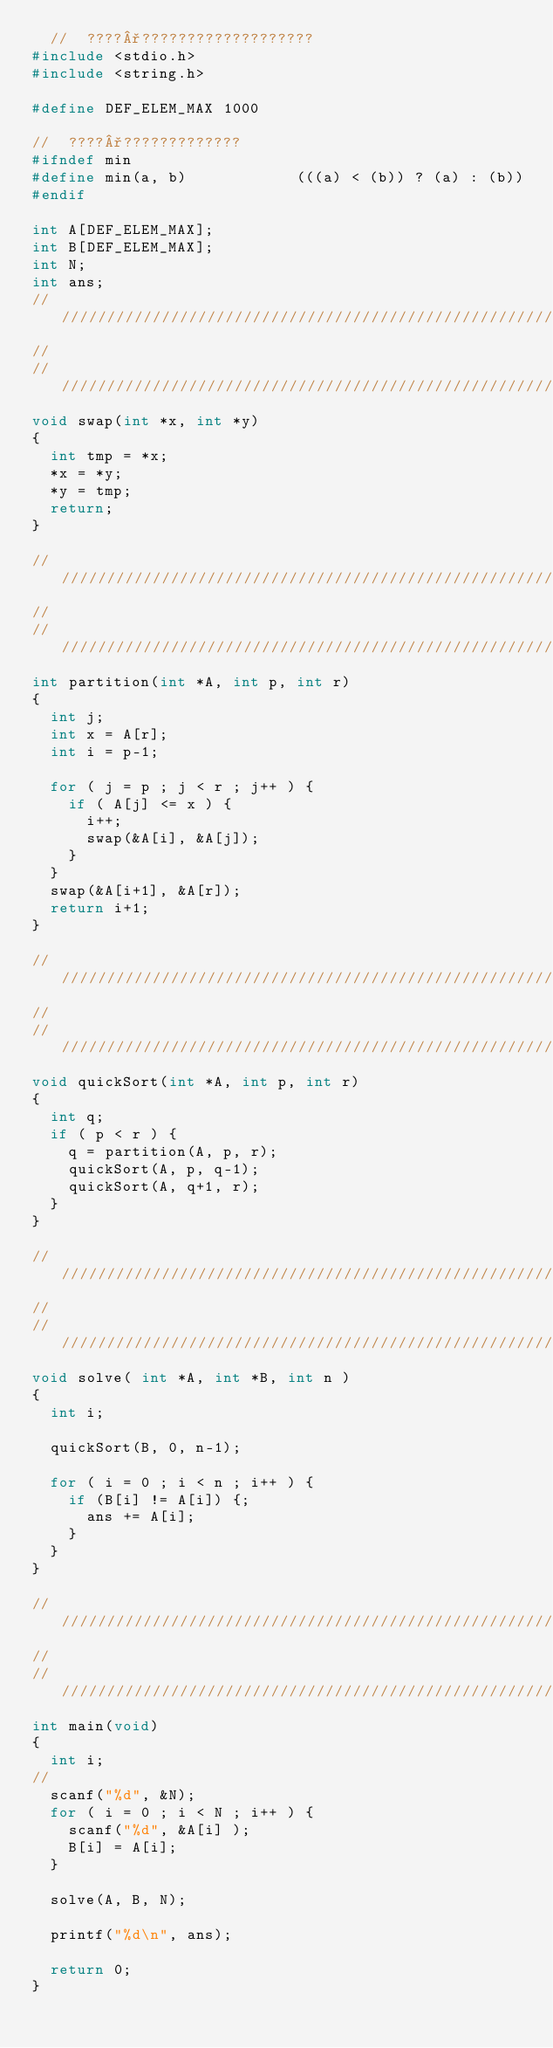Convert code to text. <code><loc_0><loc_0><loc_500><loc_500><_C_>	//	????°???????????????????
#include <stdio.h>
#include <string.h>

#define DEF_ELEM_MAX 1000

//  ????°?????????????
#ifndef min
#define min(a, b)            (((a) < (b)) ? (a) : (b))
#endif

int A[DEF_ELEM_MAX];
int B[DEF_ELEM_MAX];
int N;
int ans;
/////////////////////////////////////////////////////////////////////////////////
//
/////////////////////////////////////////////////////////////////////////////////
void swap(int *x, int *y)
{
	int tmp = *x;
	*x = *y;
	*y = tmp;
	return;
}

/////////////////////////////////////////////////////////////////////////////////
//
/////////////////////////////////////////////////////////////////////////////////
int partition(int *A, int p, int r)
{
	int j;
	int x = A[r];
	int i = p-1;

	for ( j = p ; j < r ; j++ ) {
		if ( A[j] <= x ) {
			i++;
			swap(&A[i], &A[j]);
		}
	}
	swap(&A[i+1], &A[r]);
	return i+1;
}

/////////////////////////////////////////////////////////////////////////////////
//
/////////////////////////////////////////////////////////////////////////////////
void quickSort(int *A, int p, int r)
{
	int q;
	if ( p < r ) {
		q = partition(A, p, r);
		quickSort(A, p, q-1);
		quickSort(A, q+1, r);
	}
}

/////////////////////////////////////////////////////////////////////////////////
//
/////////////////////////////////////////////////////////////////////////////////
void solve( int *A, int *B, int n )
{
	int i;

	quickSort(B, 0, n-1);

	for ( i = 0 ; i < n ; i++ ) {
		if (B[i] != A[i]) {;
			ans += A[i];
		}
	}
}

/////////////////////////////////////////////////////////////////////////////////
//
/////////////////////////////////////////////////////////////////////////////////
int main(void)
{
	int i;
//
	scanf("%d", &N);
	for ( i = 0 ; i < N ; i++ ) {
		scanf("%d", &A[i] );
		B[i] = A[i];
	}

	solve(A, B, N);

	printf("%d\n", ans);

	return 0;
}</code> 